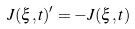Convert formula to latex. <formula><loc_0><loc_0><loc_500><loc_500>J ( \xi , t ) ^ { \prime } = - J ( \xi , t )</formula> 